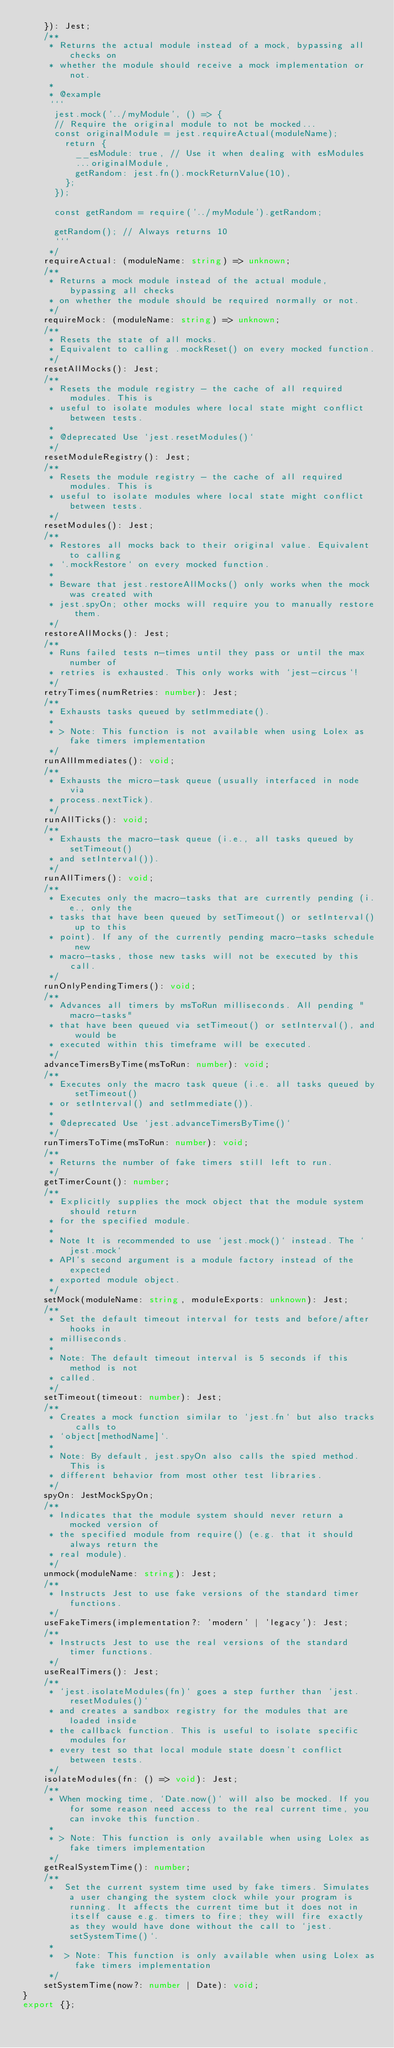Convert code to text. <code><loc_0><loc_0><loc_500><loc_500><_TypeScript_>    }): Jest;
    /**
     * Returns the actual module instead of a mock, bypassing all checks on
     * whether the module should receive a mock implementation or not.
     *
     * @example
     ```
      jest.mock('../myModule', () => {
      // Require the original module to not be mocked...
      const originalModule = jest.requireActual(moduleName);
        return {
          __esModule: true, // Use it when dealing with esModules
          ...originalModule,
          getRandom: jest.fn().mockReturnValue(10),
        };
      });
  
      const getRandom = require('../myModule').getRandom;
  
      getRandom(); // Always returns 10
      ```
     */
    requireActual: (moduleName: string) => unknown;
    /**
     * Returns a mock module instead of the actual module, bypassing all checks
     * on whether the module should be required normally or not.
     */
    requireMock: (moduleName: string) => unknown;
    /**
     * Resets the state of all mocks.
     * Equivalent to calling .mockReset() on every mocked function.
     */
    resetAllMocks(): Jest;
    /**
     * Resets the module registry - the cache of all required modules. This is
     * useful to isolate modules where local state might conflict between tests.
     *
     * @deprecated Use `jest.resetModules()`
     */
    resetModuleRegistry(): Jest;
    /**
     * Resets the module registry - the cache of all required modules. This is
     * useful to isolate modules where local state might conflict between tests.
     */
    resetModules(): Jest;
    /**
     * Restores all mocks back to their original value. Equivalent to calling
     * `.mockRestore` on every mocked function.
     *
     * Beware that jest.restoreAllMocks() only works when the mock was created with
     * jest.spyOn; other mocks will require you to manually restore them.
     */
    restoreAllMocks(): Jest;
    /**
     * Runs failed tests n-times until they pass or until the max number of
     * retries is exhausted. This only works with `jest-circus`!
     */
    retryTimes(numRetries: number): Jest;
    /**
     * Exhausts tasks queued by setImmediate().
     *
     * > Note: This function is not available when using Lolex as fake timers implementation
     */
    runAllImmediates(): void;
    /**
     * Exhausts the micro-task queue (usually interfaced in node via
     * process.nextTick).
     */
    runAllTicks(): void;
    /**
     * Exhausts the macro-task queue (i.e., all tasks queued by setTimeout()
     * and setInterval()).
     */
    runAllTimers(): void;
    /**
     * Executes only the macro-tasks that are currently pending (i.e., only the
     * tasks that have been queued by setTimeout() or setInterval() up to this
     * point). If any of the currently pending macro-tasks schedule new
     * macro-tasks, those new tasks will not be executed by this call.
     */
    runOnlyPendingTimers(): void;
    /**
     * Advances all timers by msToRun milliseconds. All pending "macro-tasks"
     * that have been queued via setTimeout() or setInterval(), and would be
     * executed within this timeframe will be executed.
     */
    advanceTimersByTime(msToRun: number): void;
    /**
     * Executes only the macro task queue (i.e. all tasks queued by setTimeout()
     * or setInterval() and setImmediate()).
     *
     * @deprecated Use `jest.advanceTimersByTime()`
     */
    runTimersToTime(msToRun: number): void;
    /**
     * Returns the number of fake timers still left to run.
     */
    getTimerCount(): number;
    /**
     * Explicitly supplies the mock object that the module system should return
     * for the specified module.
     *
     * Note It is recommended to use `jest.mock()` instead. The `jest.mock`
     * API's second argument is a module factory instead of the expected
     * exported module object.
     */
    setMock(moduleName: string, moduleExports: unknown): Jest;
    /**
     * Set the default timeout interval for tests and before/after hooks in
     * milliseconds.
     *
     * Note: The default timeout interval is 5 seconds if this method is not
     * called.
     */
    setTimeout(timeout: number): Jest;
    /**
     * Creates a mock function similar to `jest.fn` but also tracks calls to
     * `object[methodName]`.
     *
     * Note: By default, jest.spyOn also calls the spied method. This is
     * different behavior from most other test libraries.
     */
    spyOn: JestMockSpyOn;
    /**
     * Indicates that the module system should never return a mocked version of
     * the specified module from require() (e.g. that it should always return the
     * real module).
     */
    unmock(moduleName: string): Jest;
    /**
     * Instructs Jest to use fake versions of the standard timer functions.
     */
    useFakeTimers(implementation?: 'modern' | 'legacy'): Jest;
    /**
     * Instructs Jest to use the real versions of the standard timer functions.
     */
    useRealTimers(): Jest;
    /**
     * `jest.isolateModules(fn)` goes a step further than `jest.resetModules()`
     * and creates a sandbox registry for the modules that are loaded inside
     * the callback function. This is useful to isolate specific modules for
     * every test so that local module state doesn't conflict between tests.
     */
    isolateModules(fn: () => void): Jest;
    /**
     * When mocking time, `Date.now()` will also be mocked. If you for some reason need access to the real current time, you can invoke this function.
     *
     * > Note: This function is only available when using Lolex as fake timers implementation
     */
    getRealSystemTime(): number;
    /**
     *  Set the current system time used by fake timers. Simulates a user changing the system clock while your program is running. It affects the current time but it does not in itself cause e.g. timers to fire; they will fire exactly as they would have done without the call to `jest.setSystemTime()`.
     *
     *  > Note: This function is only available when using Lolex as fake timers implementation
     */
    setSystemTime(now?: number | Date): void;
}
export {};
</code> 